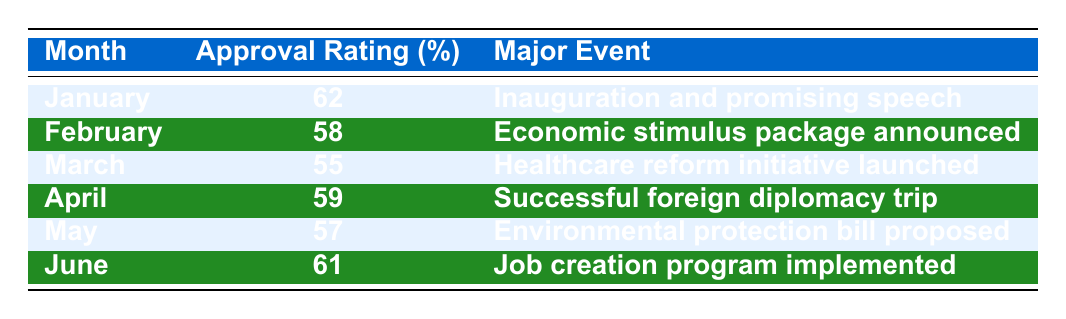What was the approval rating in January? The table shows that in January, the approval rating was 62%.
Answer: 62% Which month had the lowest approval rating? By checking the Approval Rating column, March has the lowest approval rating of 55%.
Answer: March What was the average approval rating across the six months? To find the average, sum the approval ratings (62 + 58 + 55 + 59 + 57 + 61 = 352) and divide by the number of months (6). Thus, the average is 352/6 ≈ 58.67.
Answer: 58.67 Did Jenna's approval rating increase from May to June? In May, the approval rating was 57%, and in June it increased to 61%. Therefore, it did increase.
Answer: Yes What major event coincided with the approval rating of 59%? In April, the approval rating was 59%, which coincided with the successful foreign diplomacy trip.
Answer: Successful foreign diplomacy trip How much did the approval rating drop from February to March? The approval rating in February was 58%, and it dropped to 55% in March. The difference is 58 - 55 = 3.
Answer: 3 Was there any month where the approval rating was above 60%? Yes, there were two months: January (62%) and June (61%).
Answer: Yes Which months had approval ratings lower than 60%? The months with approval ratings lower than 60% are February (58%), March (55%), and May (57%).
Answer: February, March, May What was the change in approval rating from January to April? The approval rating dropped from January's 62% to April's 59%, resulting in a decrease of 3%.
Answer: 3% decrease 